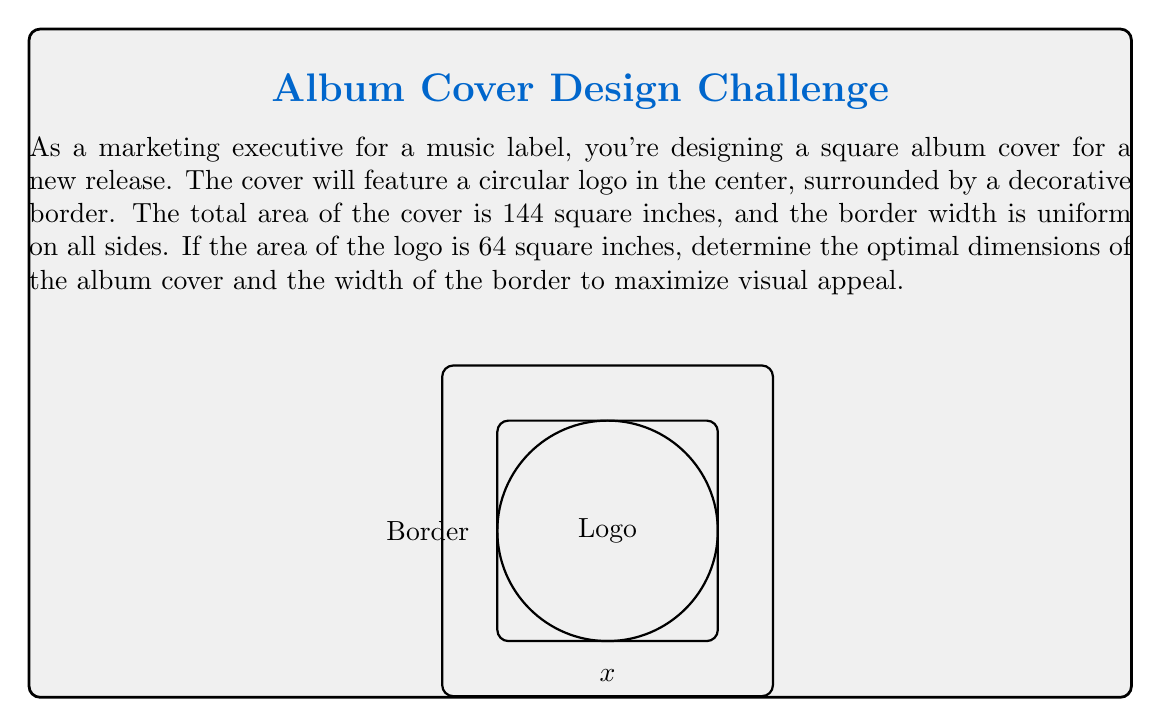Help me with this question. Let's approach this step-by-step:

1) Let $x$ be the side length of the square album cover. The area of the cover is given as 144 square inches.

   $$x^2 = 144$$
   $$x = 12 \text{ inches}$$

2) Let $r$ be the radius of the circular logo. We're told the area of the logo is 64 square inches.

   $$\pi r^2 = 64$$
   $$r^2 = \frac{64}{\pi}$$
   $$r = 4\sqrt{\frac{1}{\pi}} \approx 4.51 \text{ inches}$$

3) Let $w$ be the width of the border. We can express $w$ in terms of $x$ and $r$:

   $$w = \frac{x - 2r}{2}$$

4) Substituting the values we know:

   $$w = \frac{12 - 2(4\sqrt{\frac{1}{\pi}})}{2}$$
   $$w = 6 - 4\sqrt{\frac{1}{\pi}}$$
   $$w \approx 1.49 \text{ inches}$$

5) To verify, we can check that the border area plus the logo area equals the total area:

   Border area: $12^2 - \pi(4.51)^2 \approx 80$ sq inches
   Logo area: $64$ sq inches
   Total: $80 + 64 = 144$ sq inches

Therefore, the optimal dimensions for the album cover are 12 inches by 12 inches, with a border width of approximately 1.49 inches.
Answer: 12" x 12" cover, 1.49" border width 